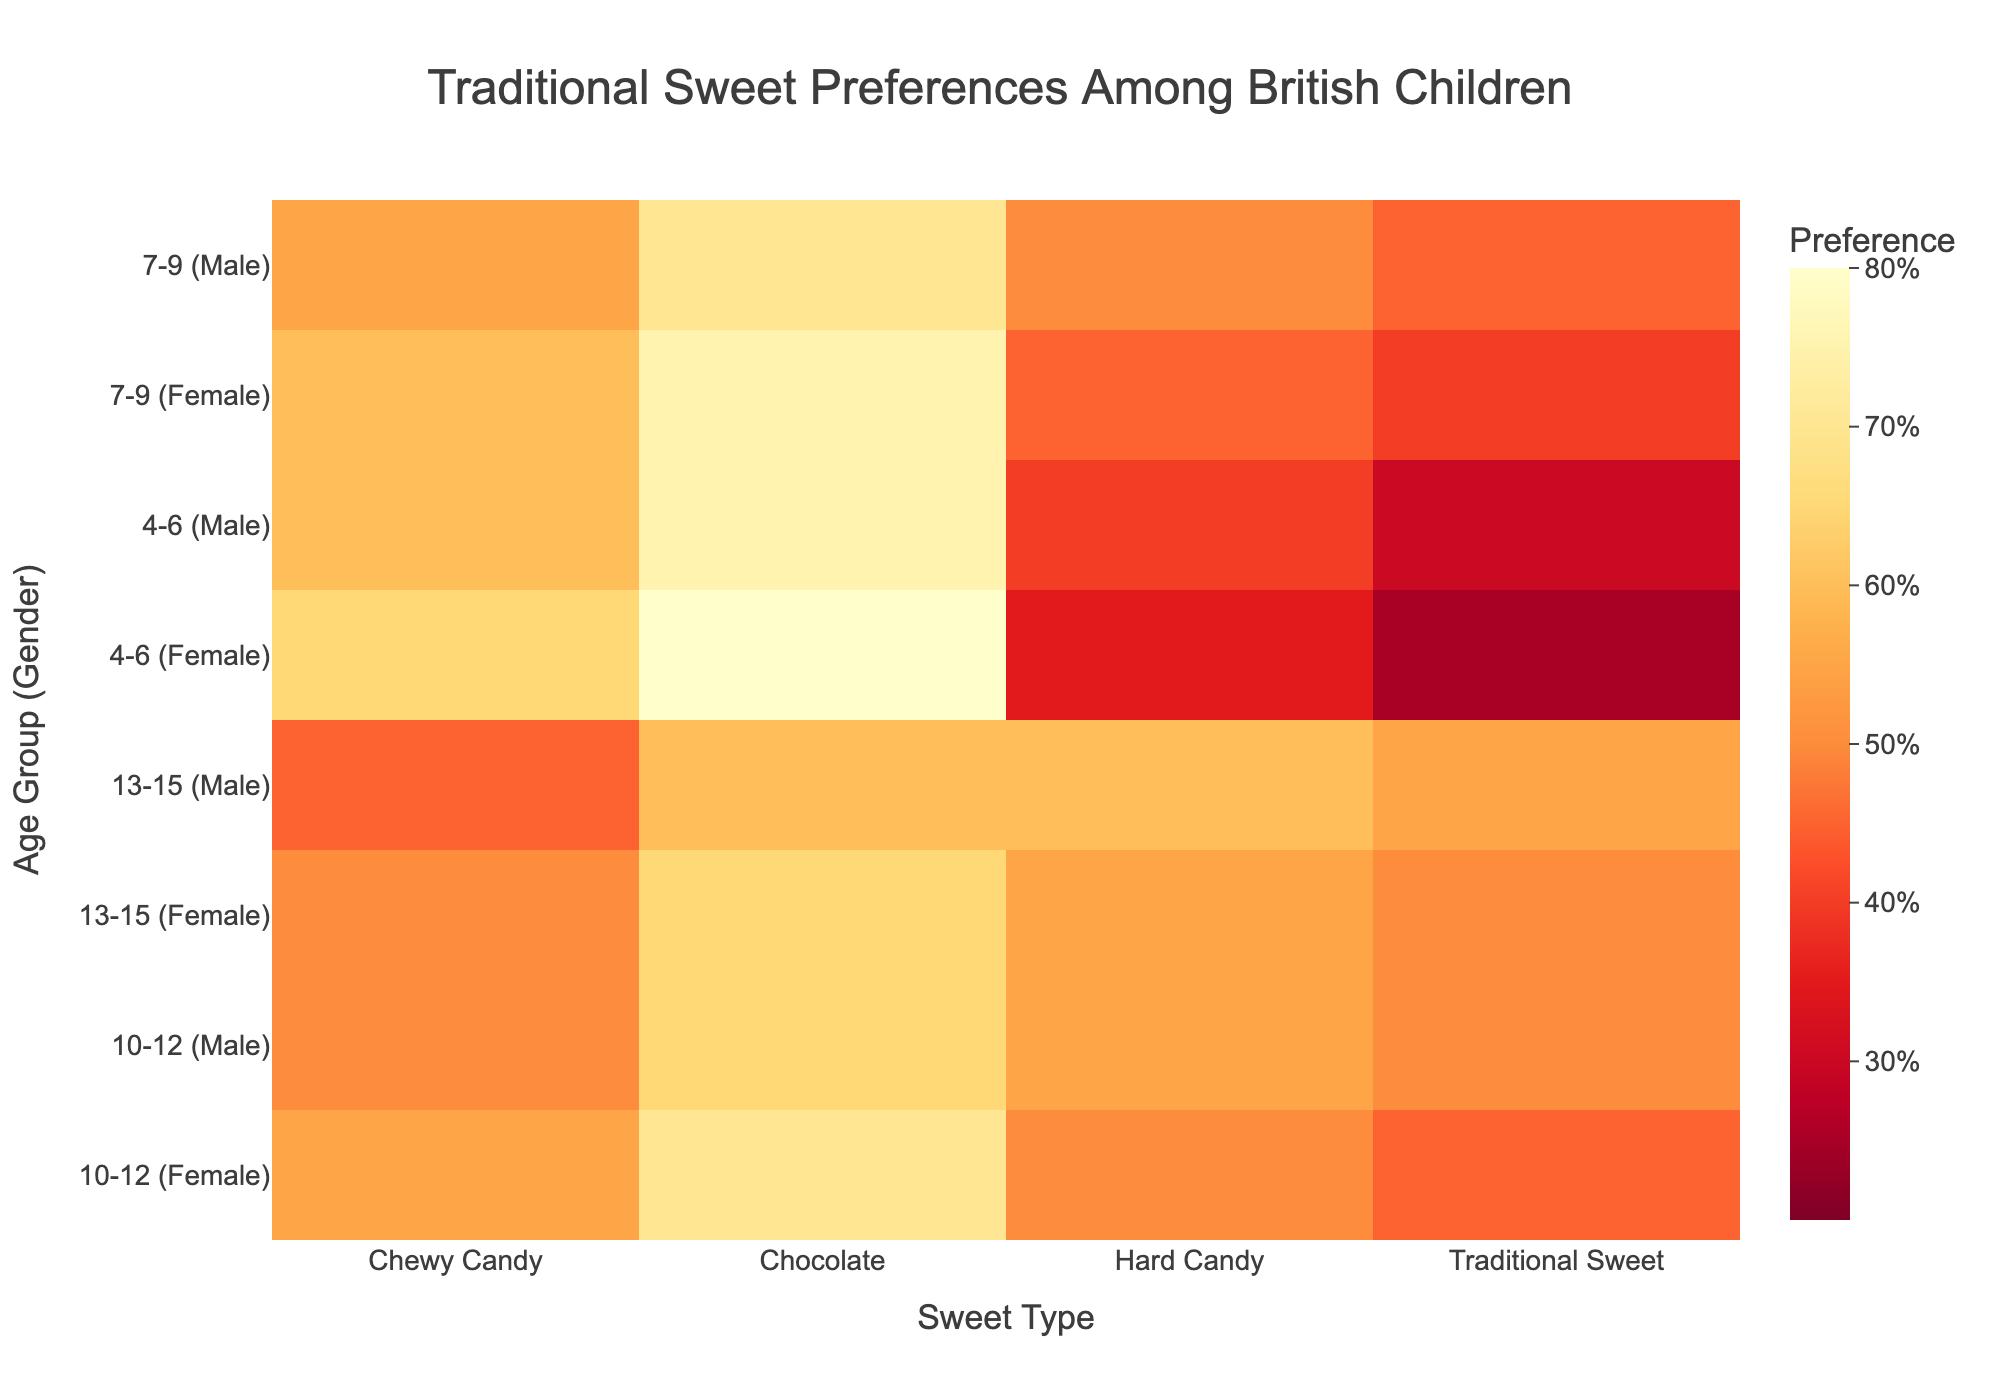Which age group and gender combination has the highest preference for chocolate? Look at the row with the highest value for chocolate in the heatmap. The "4-6 (Female)" group shows the highest preference with a value of 80.
Answer: 4-6 (Female) What is the average preference for traditional sweets across all age groups and genders? Sum the preferences for traditional sweets across all groups and divide by the number of groups (30+25+45+40+50+45+55+50=340, 340/8). The average preference is 42.5.
Answer: 42.5 Which sweet type has the most consistent preference across different age and gender groups? Compare the variation range (difference between maximum and minimum values) for each sweet type. Traditional Sweet has the smallest variation range, from 25 to 55.
Answer: Traditional Sweet How does the preference for chewy candy change from the youngest to the oldest age group for males? For males, the values are 60 (4-6), 55 (7-9), 50 (10-12), and 45 (13-15), indicating a decrease as age increases.
Answer: Decreases What is the difference in preference for hard candy between girls aged 7-9 and boys aged 10-12? Subtract the value for boys aged 10-12 (55) from the value for girls aged 7-9 (45). The difference is 45 - 55 = -10.
Answer: -10 Which age-group and gender combination exhibits the highest overall preference for sweets (sum of all sweet types)? Find the row where the sum of preferences is highest. The "4-6 (Female)" group has the highest total preference: 80 + 35 + 65 + 25 = 205.
Answer: 4-6 (Female) What is the trend in preference for traditional sweets among females from youngest to oldest? For females, the values are 25 (4-6), 40 (7-9), 45 (10-12), and 50 (13-15), indicating an increase as age increases.
Answer: Increases Between the age groups 7-9 and 10-12, which gender shows a larger change in chocolate preference? Calculate the change for each gender. Males: 70 - 65 = 5. Females: 75 - 70 = 5. Both show the same change of 5.
Answer: Both Which sweet type do older boys (13-15) prefer the most? Look at the preferences for boys aged 13-15. The highest value is 60 for hard candy.
Answer: Hard Candy 